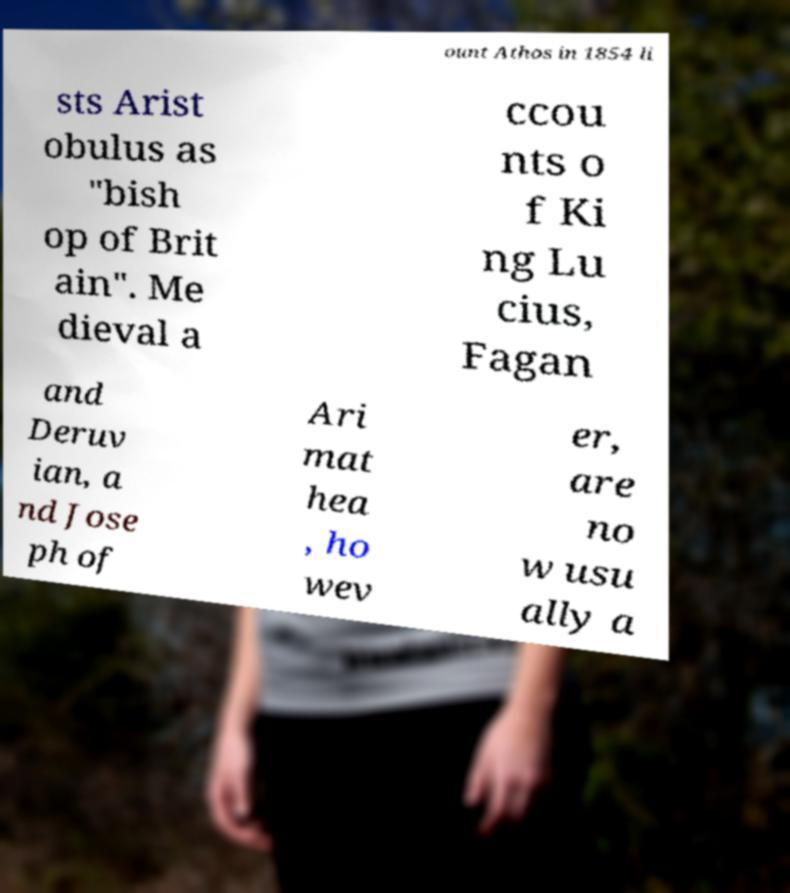What messages or text are displayed in this image? I need them in a readable, typed format. ount Athos in 1854 li sts Arist obulus as "bish op of Brit ain". Me dieval a ccou nts o f Ki ng Lu cius, Fagan and Deruv ian, a nd Jose ph of Ari mat hea , ho wev er, are no w usu ally a 